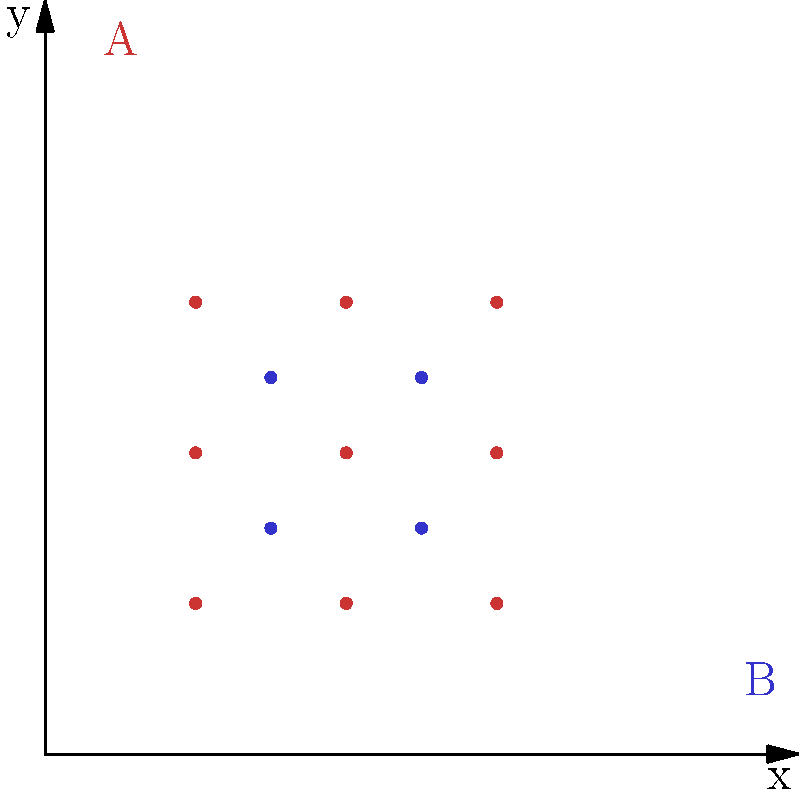In the image above, nanoparticles of two types (A and B) are arranged in a specific pattern for targeted drug delivery. If this pattern is extended infinitely in all directions, what is the ratio of type A nanoparticles to type B nanoparticles? To solve this problem, we need to analyze the pattern of nanoparticles and determine the relative frequencies of each type:

1. Observe the pattern:
   - Type A nanoparticles (red) form a 3x3 grid
   - Type B nanoparticles (blue) form a 2x2 grid within the spaces of the Type A grid

2. Count the nanoparticles in one complete unit of the pattern:
   - Type A: 3 x 3 = 9 nanoparticles
   - Type B: 2 x 2 = 4 nanoparticles

3. Calculate the ratio:
   - Ratio of A to B = 9 : 4

4. Simplify the ratio:
   - Divide both numbers by their greatest common divisor (1)
   - Simplified ratio: 9 : 4

Therefore, the ratio of type A nanoparticles to type B nanoparticles is 9:4.
Answer: 9:4 